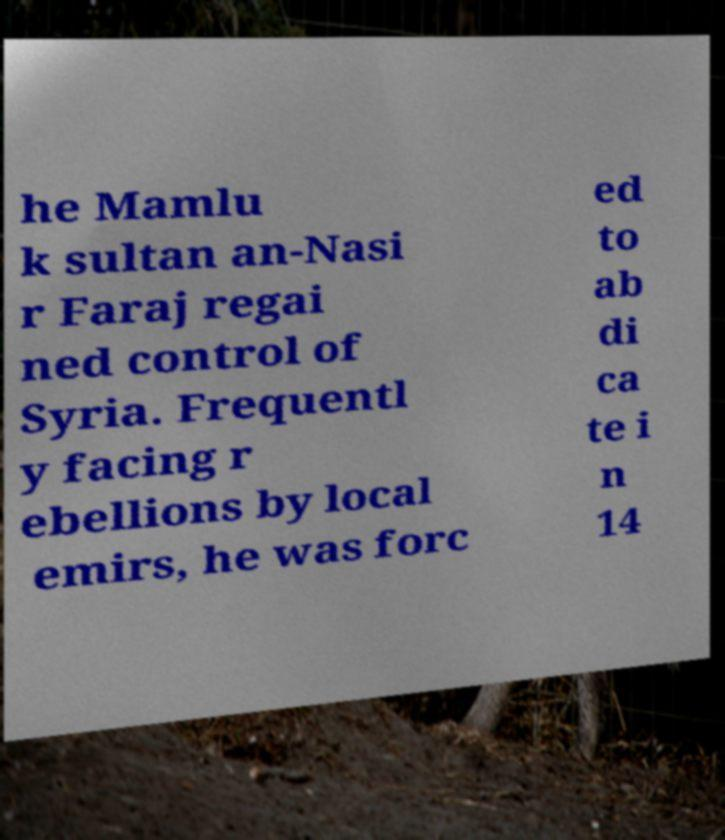Can you accurately transcribe the text from the provided image for me? he Mamlu k sultan an-Nasi r Faraj regai ned control of Syria. Frequentl y facing r ebellions by local emirs, he was forc ed to ab di ca te i n 14 